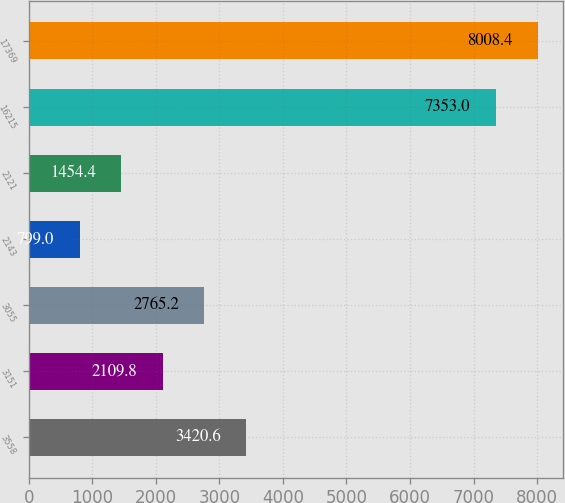Convert chart. <chart><loc_0><loc_0><loc_500><loc_500><bar_chart><fcel>3558<fcel>3151<fcel>3055<fcel>2143<fcel>2121<fcel>16215<fcel>17369<nl><fcel>3420.6<fcel>2109.8<fcel>2765.2<fcel>799<fcel>1454.4<fcel>7353<fcel>8008.4<nl></chart> 